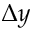<formula> <loc_0><loc_0><loc_500><loc_500>\Delta y</formula> 